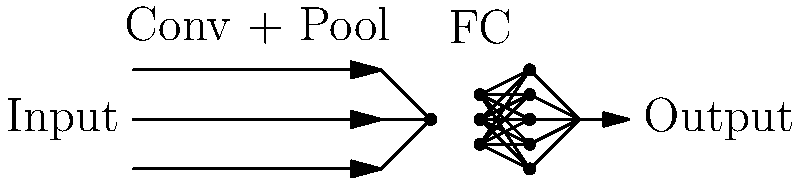As a theoretical physicist familiar with complex diagrams, identify the type of neural network architecture represented in this schematic. How does its structure relate to the principles of information flow and transformation in quantum systems? To identify this neural network architecture and relate it to quantum systems, let's analyze the diagram step-by-step:

1. Input layer: We see three parallel arrows entering the network, suggesting multiple input channels or features.

2. Convolutional and Pooling layers: The first part of the network is labeled "Conv + Pool", indicating convolutional and pooling operations. These layers are analogous to local quantum operations that transform input states.

3. Fully Connected (FC) layers: The latter part of the network shows densely connected nodes, representing fully connected layers. This is similar to entanglement in quantum systems, where all qubits can potentially interact.

4. Output layer: A single arrow emerges, representing the final output.

This structure is characteristic of a Convolutional Neural Network (CNN). The information flow in this network can be related to quantum systems as follows:

a) Local operations (convolutions) followed by global operations (fully connected layers) mirror the concept of local and non-local quantum operations.

b) The pooling layers can be thought of as a form of coarse-graining, similar to renormalization group techniques used in quantum field theory.

c) The fully connected layers represent a high degree of entanglement, where each node (qubit) is connected to every node in the next layer.

d) The overall structure of extracting features (convolutions) and then making decisions (fully connected layers) is analogous to how quantum measurements work: first interacting with a system locally, then collapsing the wavefunction globally.

This CNN architecture, therefore, shares conceptual similarities with quantum information processing, making it an interesting bridge between classical machine learning and quantum mechanics.
Answer: Convolutional Neural Network (CNN) 